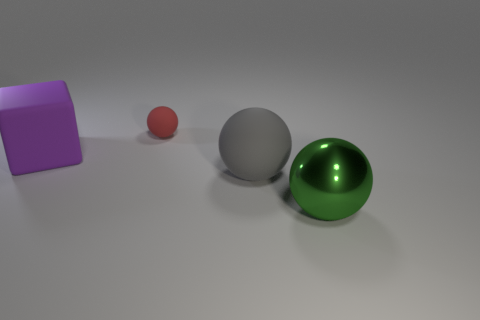What is the small red sphere made of?
Offer a very short reply. Rubber. Is the color of the rubber sphere that is behind the big gray thing the same as the thing in front of the gray thing?
Provide a succinct answer. No. Are there more things than tiny brown cylinders?
Your response must be concise. Yes. How many other cubes are the same color as the large block?
Give a very brief answer. 0. What is the color of the big matte object that is the same shape as the tiny object?
Your answer should be compact. Gray. There is a large object that is behind the green object and right of the purple block; what material is it?
Offer a very short reply. Rubber. Does the thing that is behind the rubber block have the same material as the big ball that is on the left side of the green metallic thing?
Keep it short and to the point. Yes. What size is the green object?
Provide a succinct answer. Large. What is the size of the other matte thing that is the same shape as the red matte thing?
Ensure brevity in your answer.  Large. How many tiny red rubber things are behind the large purple block?
Provide a succinct answer. 1. 